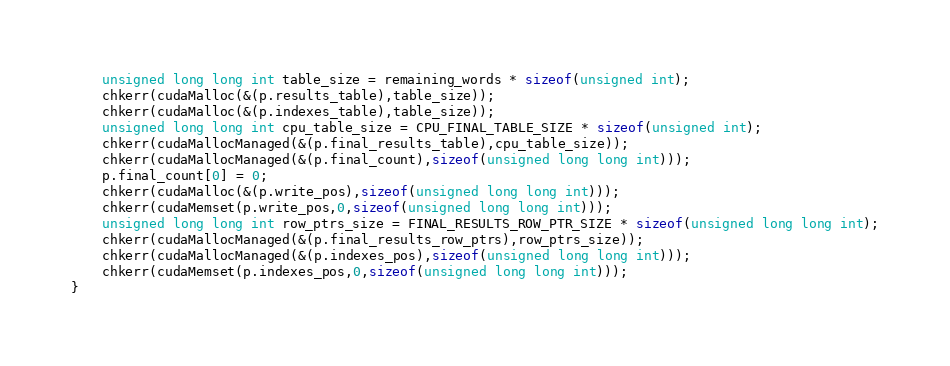Convert code to text. <code><loc_0><loc_0><loc_500><loc_500><_Cuda_>    unsigned long long int table_size = remaining_words * sizeof(unsigned int);
    chkerr(cudaMalloc(&(p.results_table),table_size));
    chkerr(cudaMalloc(&(p.indexes_table),table_size));
    unsigned long long int cpu_table_size = CPU_FINAL_TABLE_SIZE * sizeof(unsigned int);
    chkerr(cudaMallocManaged(&(p.final_results_table),cpu_table_size));
    chkerr(cudaMallocManaged(&(p.final_count),sizeof(unsigned long long int)));
    p.final_count[0] = 0;
    chkerr(cudaMalloc(&(p.write_pos),sizeof(unsigned long long int)));
    chkerr(cudaMemset(p.write_pos,0,sizeof(unsigned long long int)));
    unsigned long long int row_ptrs_size = FINAL_RESULTS_ROW_PTR_SIZE * sizeof(unsigned long long int);
    chkerr(cudaMallocManaged(&(p.final_results_row_ptrs),row_ptrs_size));
    chkerr(cudaMallocManaged(&(p.indexes_pos),sizeof(unsigned long long int)));
    chkerr(cudaMemset(p.indexes_pos,0,sizeof(unsigned long long int)));
}
</code> 